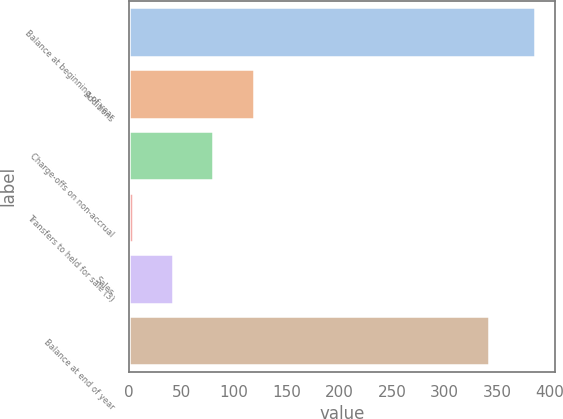<chart> <loc_0><loc_0><loc_500><loc_500><bar_chart><fcel>Balance at beginning of year<fcel>Additions<fcel>Charge-offs on non-accrual<fcel>Transfers to held for sale (3)<fcel>Sales<fcel>Balance at end of year<nl><fcel>386<fcel>118.6<fcel>80.4<fcel>4<fcel>42.2<fcel>342<nl></chart> 